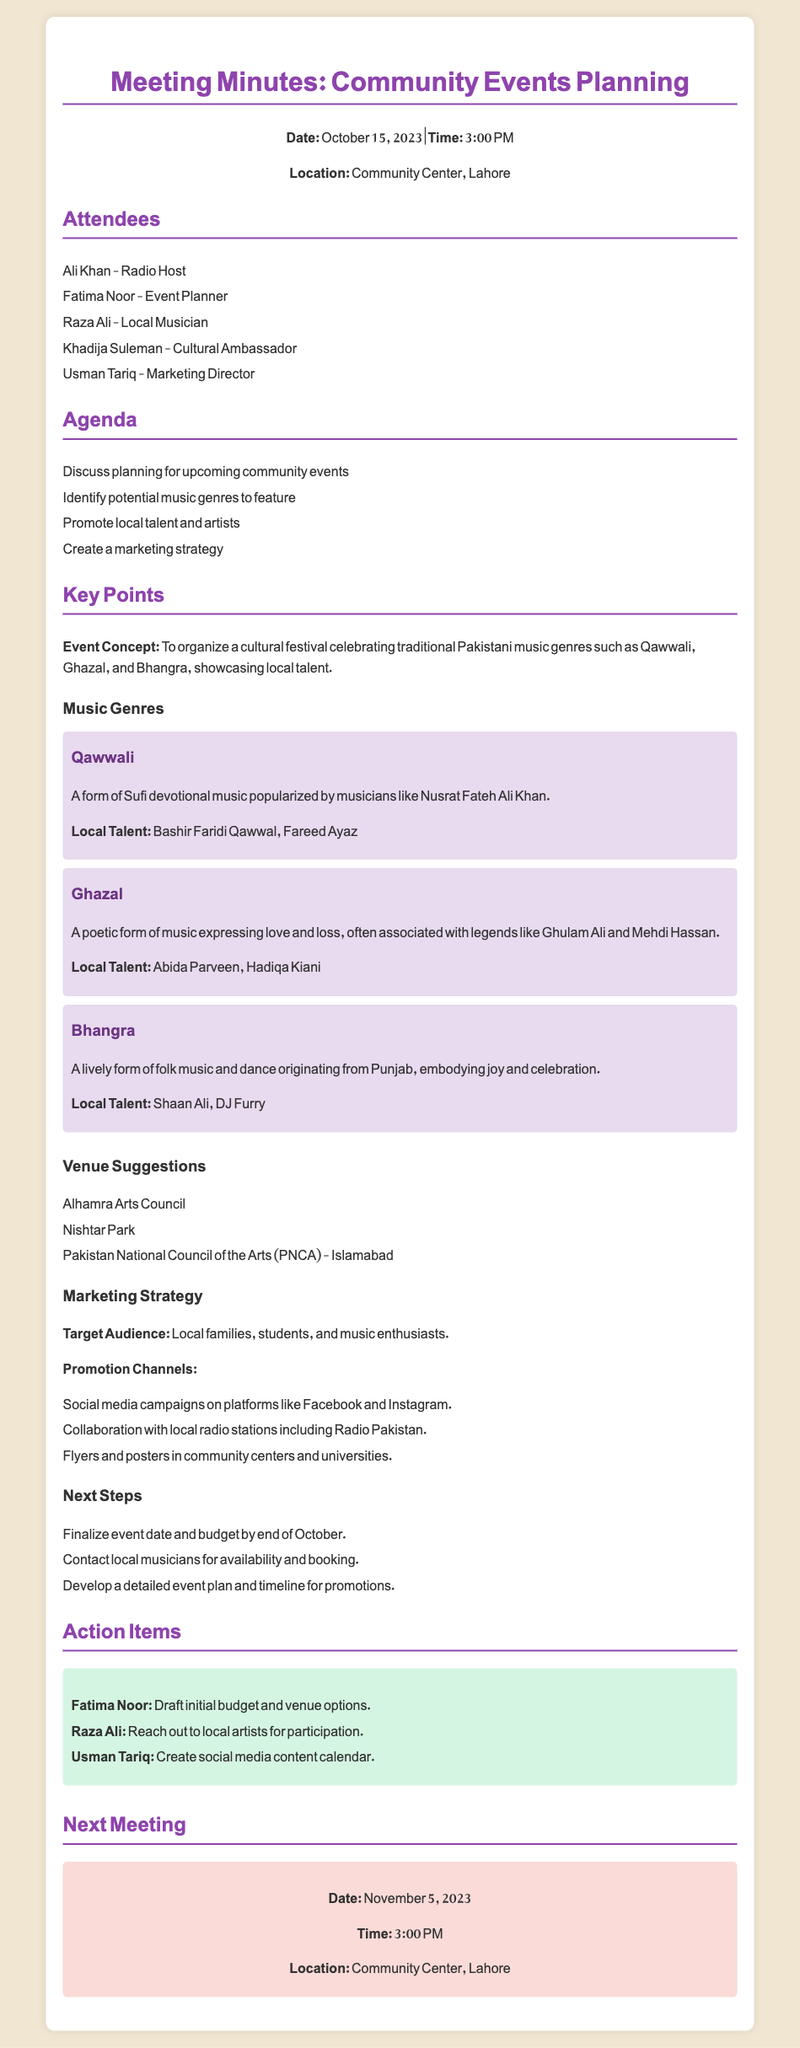What is the date of the meeting? The date of the meeting is mentioned at the beginning of the document as October 15, 2023.
Answer: October 15, 2023 Who is listed as the Cultural Ambassador? The document lists Khadija Suleman as the Cultural Ambassador among the attendees.
Answer: Khadija Suleman Which music genre is associated with Nusrat Fateh Ali Khan? The document specifies that Qawwali is a form of Sufi devotional music popularized by Nusrat Fateh Ali Khan.
Answer: Qawwali What type of marketing strategy is suggested for the events? The document states that social media campaigns on platforms like Facebook and Instagram are part of the marketing strategy.
Answer: Social media campaigns How many venues are suggested in the meeting minutes? The document lists three suggested venues for the events, which can be counted directly from the text.
Answer: Three What is Raza Ali's action item? The document states that Raza Ali's action item is to reach out to local artists for participation in the events.
Answer: Reach out to local artists When is the next meeting scheduled? The section regarding the next meeting provides details on its date and time, which is November 5, 2023, at 3:00 PM.
Answer: November 5, 2023 What is the target audience for the community events? The document identifies local families, students, and music enthusiasts as the target audience for the community events.
Answer: Local families, students, and music enthusiasts 